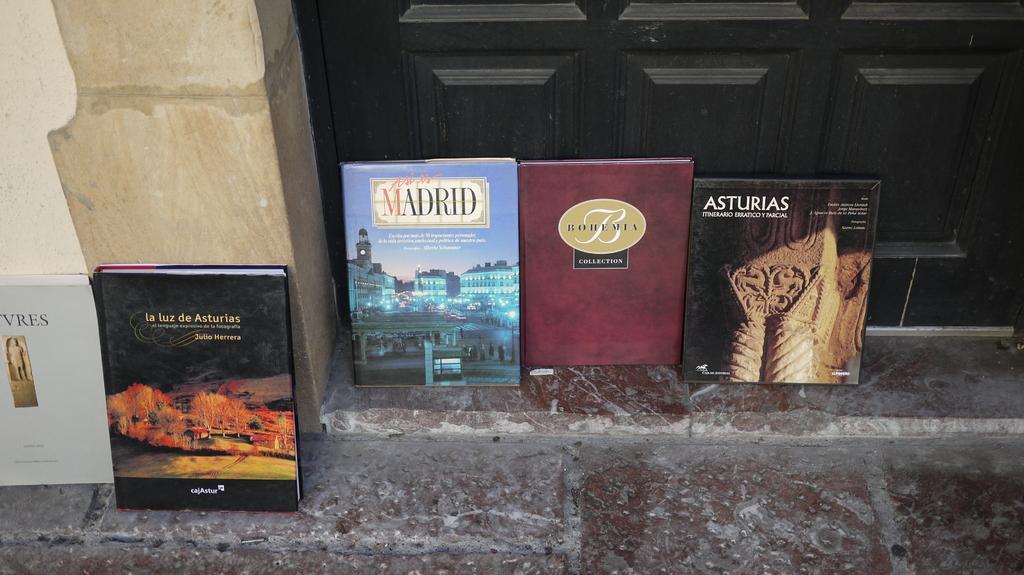How would you summarize this image in a sentence or two? In this image I can see few books in the front and in the background I can see a black colour thing which looks like a door. 